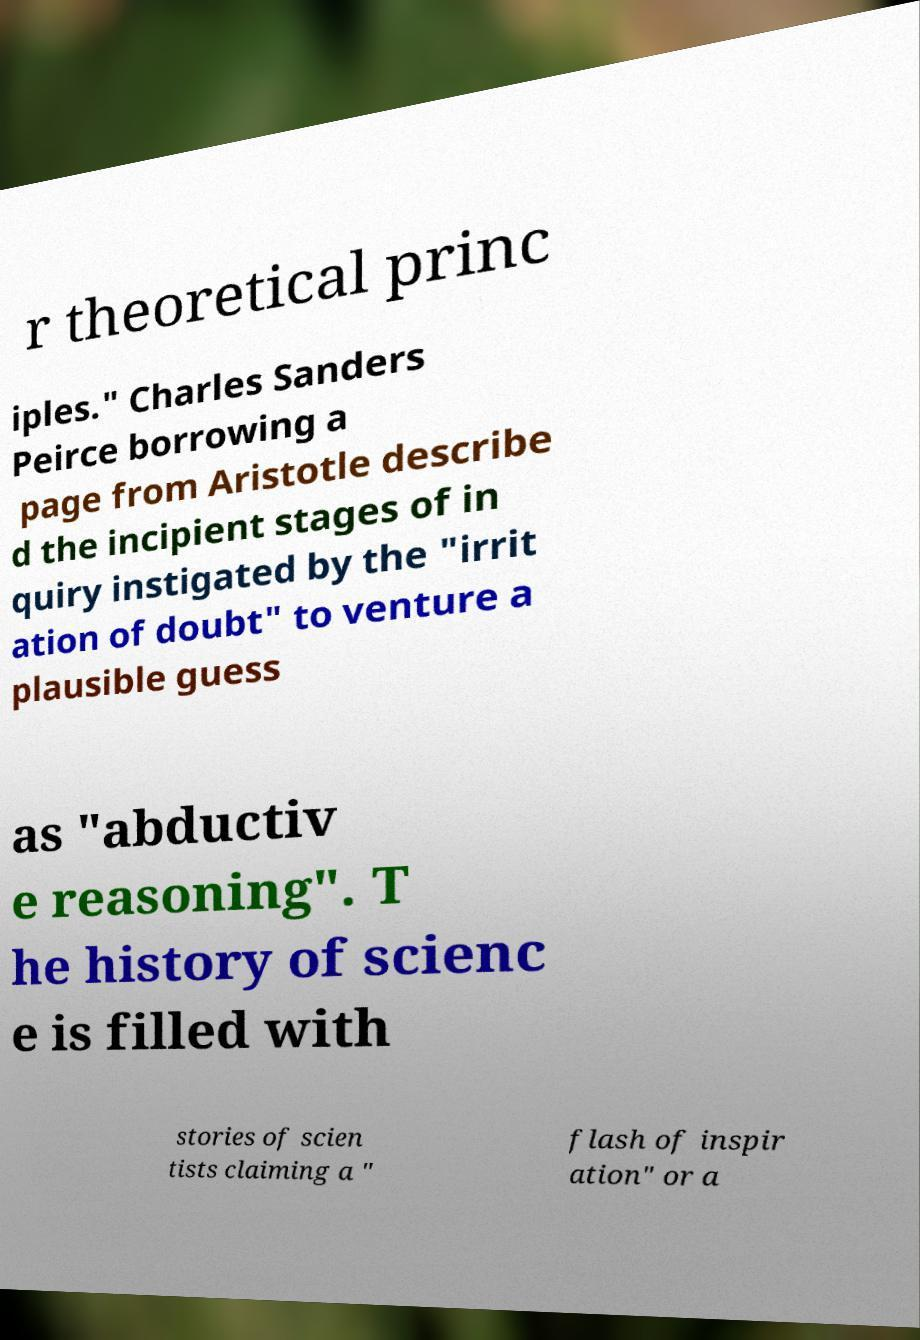Can you read and provide the text displayed in the image?This photo seems to have some interesting text. Can you extract and type it out for me? r theoretical princ iples." Charles Sanders Peirce borrowing a page from Aristotle describe d the incipient stages of in quiry instigated by the "irrit ation of doubt" to venture a plausible guess as "abductiv e reasoning". T he history of scienc e is filled with stories of scien tists claiming a " flash of inspir ation" or a 